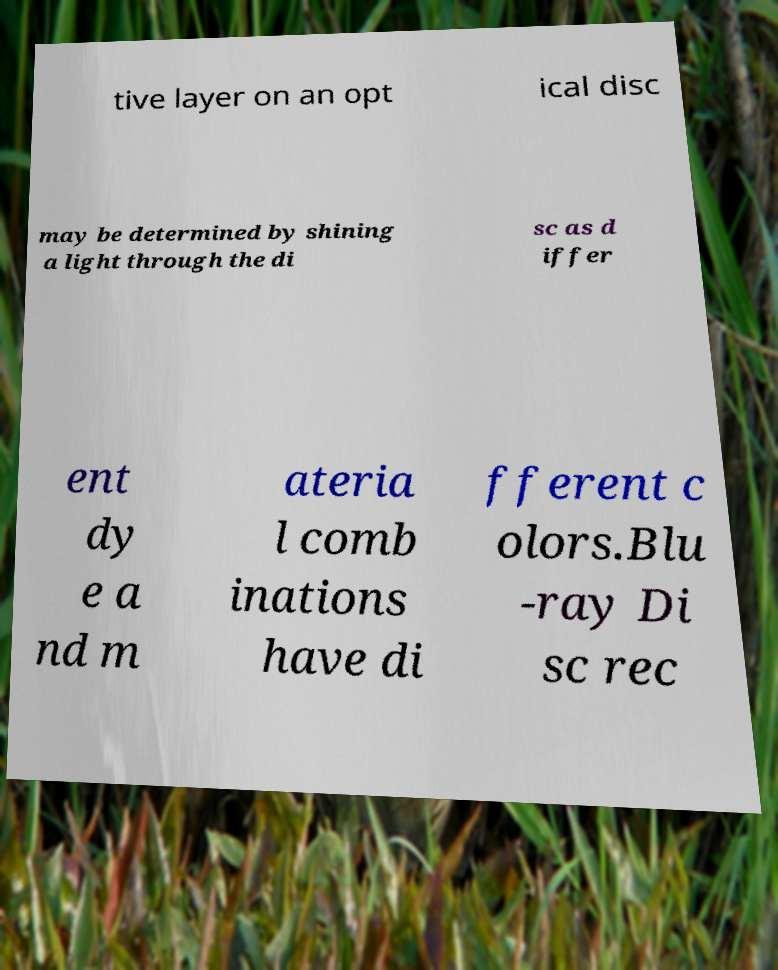Please identify and transcribe the text found in this image. tive layer on an opt ical disc may be determined by shining a light through the di sc as d iffer ent dy e a nd m ateria l comb inations have di fferent c olors.Blu -ray Di sc rec 